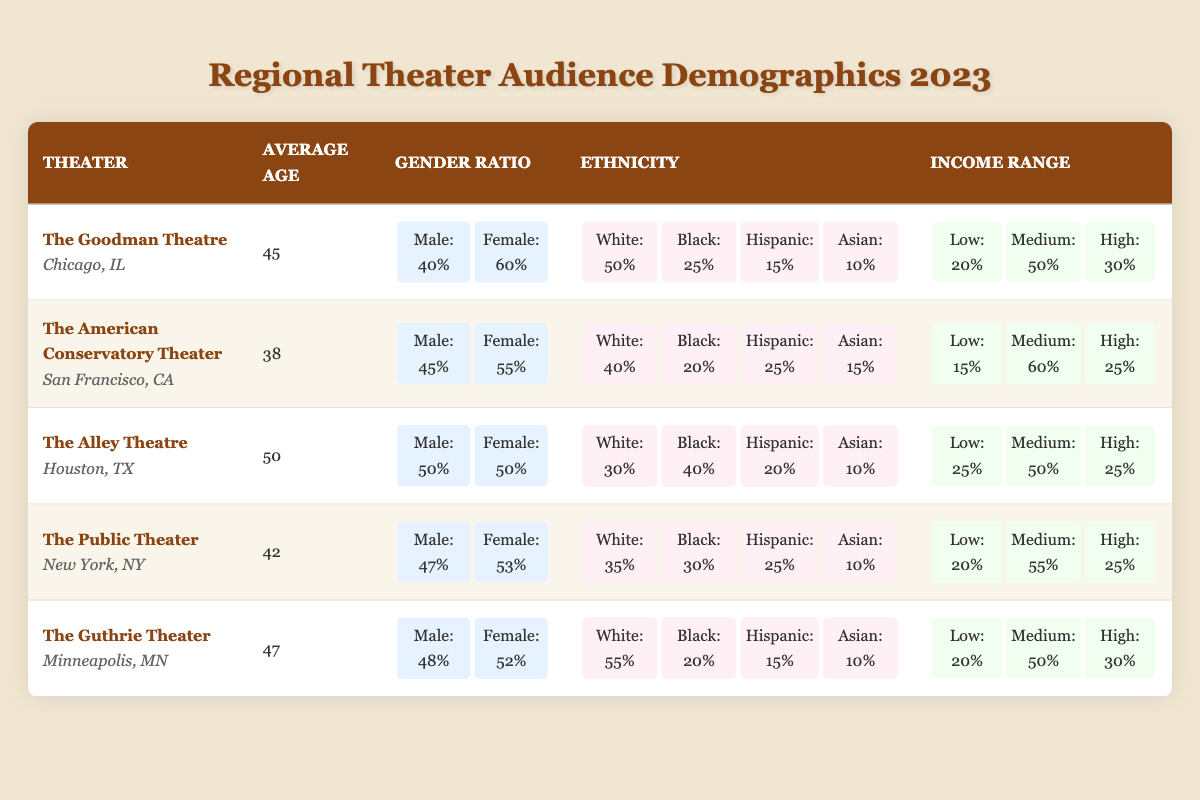What is the average age of the audience at The Alley Theatre? The table lists the average age for The Alley Theatre as 50.
Answer: 50 Which theater has the highest percentage of female audience members? By examining the gender ratio for each theater, The Goodman Theatre has 60% female audience members, which is the highest percentage listed.
Answer: The Goodman Theatre What percentage of the audience at The Public Theater is Black? The table indicates that 30% of the audience at The Public Theater identifies as Black.
Answer: 30% How does the average age of the audience at The American Conservatory Theater compare to that of The Goodman Theatre? The average age at The American Conservatory Theater is 38, while at The Goodman Theatre it is 45. Therefore, The American Conservatory Theater has a younger audience by 7 years (45 - 38 = 7).
Answer: 7 years younger What is the total percentage of Hispanic and Asian audience members at The Guthrie Theater? At The Guthrie Theater, 15% of the audience is Hispanic and 10% is Asian. Thus, the total percentage of these two groups is 15 + 10 = 25%.
Answer: 25% Is the diversity of the audience at The Alley Theatre higher than that at The Goodman Theatre in terms of ethnicity? The Alley Theatre has 30% White, 40% Black, 20% Hispanic, and 10% Asian, while The Goodman Theatre has 50% White, 25% Black, 15% Hispanic, and 10% Asian. Comparing diversity based on ethnic representation suggests that The Alley Theatre has a more balanced representation of Black (40%) compared to The Goodman Theatre (25%). Based on individual ethnic representation, it can be considered that The Alley Theatre has a slightly higher level of diversity.
Answer: Yes What is the average income range for the audience at The American Conservatory Theater? The income range for The American Conservatory Theater specifies 15% Low, 60% Medium, and 25% High. The average can be scaled roughly based on importance where Medium income range is dominant.
Answer: 60% Medium Which theater shows the least percentage of Low-income audience members? By checking each theater's income range, The American Conservatory Theater has the least percentage at 15% Low income.
Answer: The American Conservatory Theater How many theaters have an equal gender ratio? Reviewing the data indicates that The Alley Theatre is the only theater with an equal gender ratio of 50% Male and 50% Female.
Answer: 1 Theater What is the income percentage for high-income groups across all theaters compared? Collecting the high-income percentages: Goodman Theatre (30%) + American Conservatory Theater (25%) + Alley Theatre (25%) + Public Theater (25%) + Guthrie Theater (30%) = 30 + 25 + 25 + 25 + 30 = 135%. Therefore, there are a total of 135% in high-income groups across all listed theaters.
Answer: 135% 